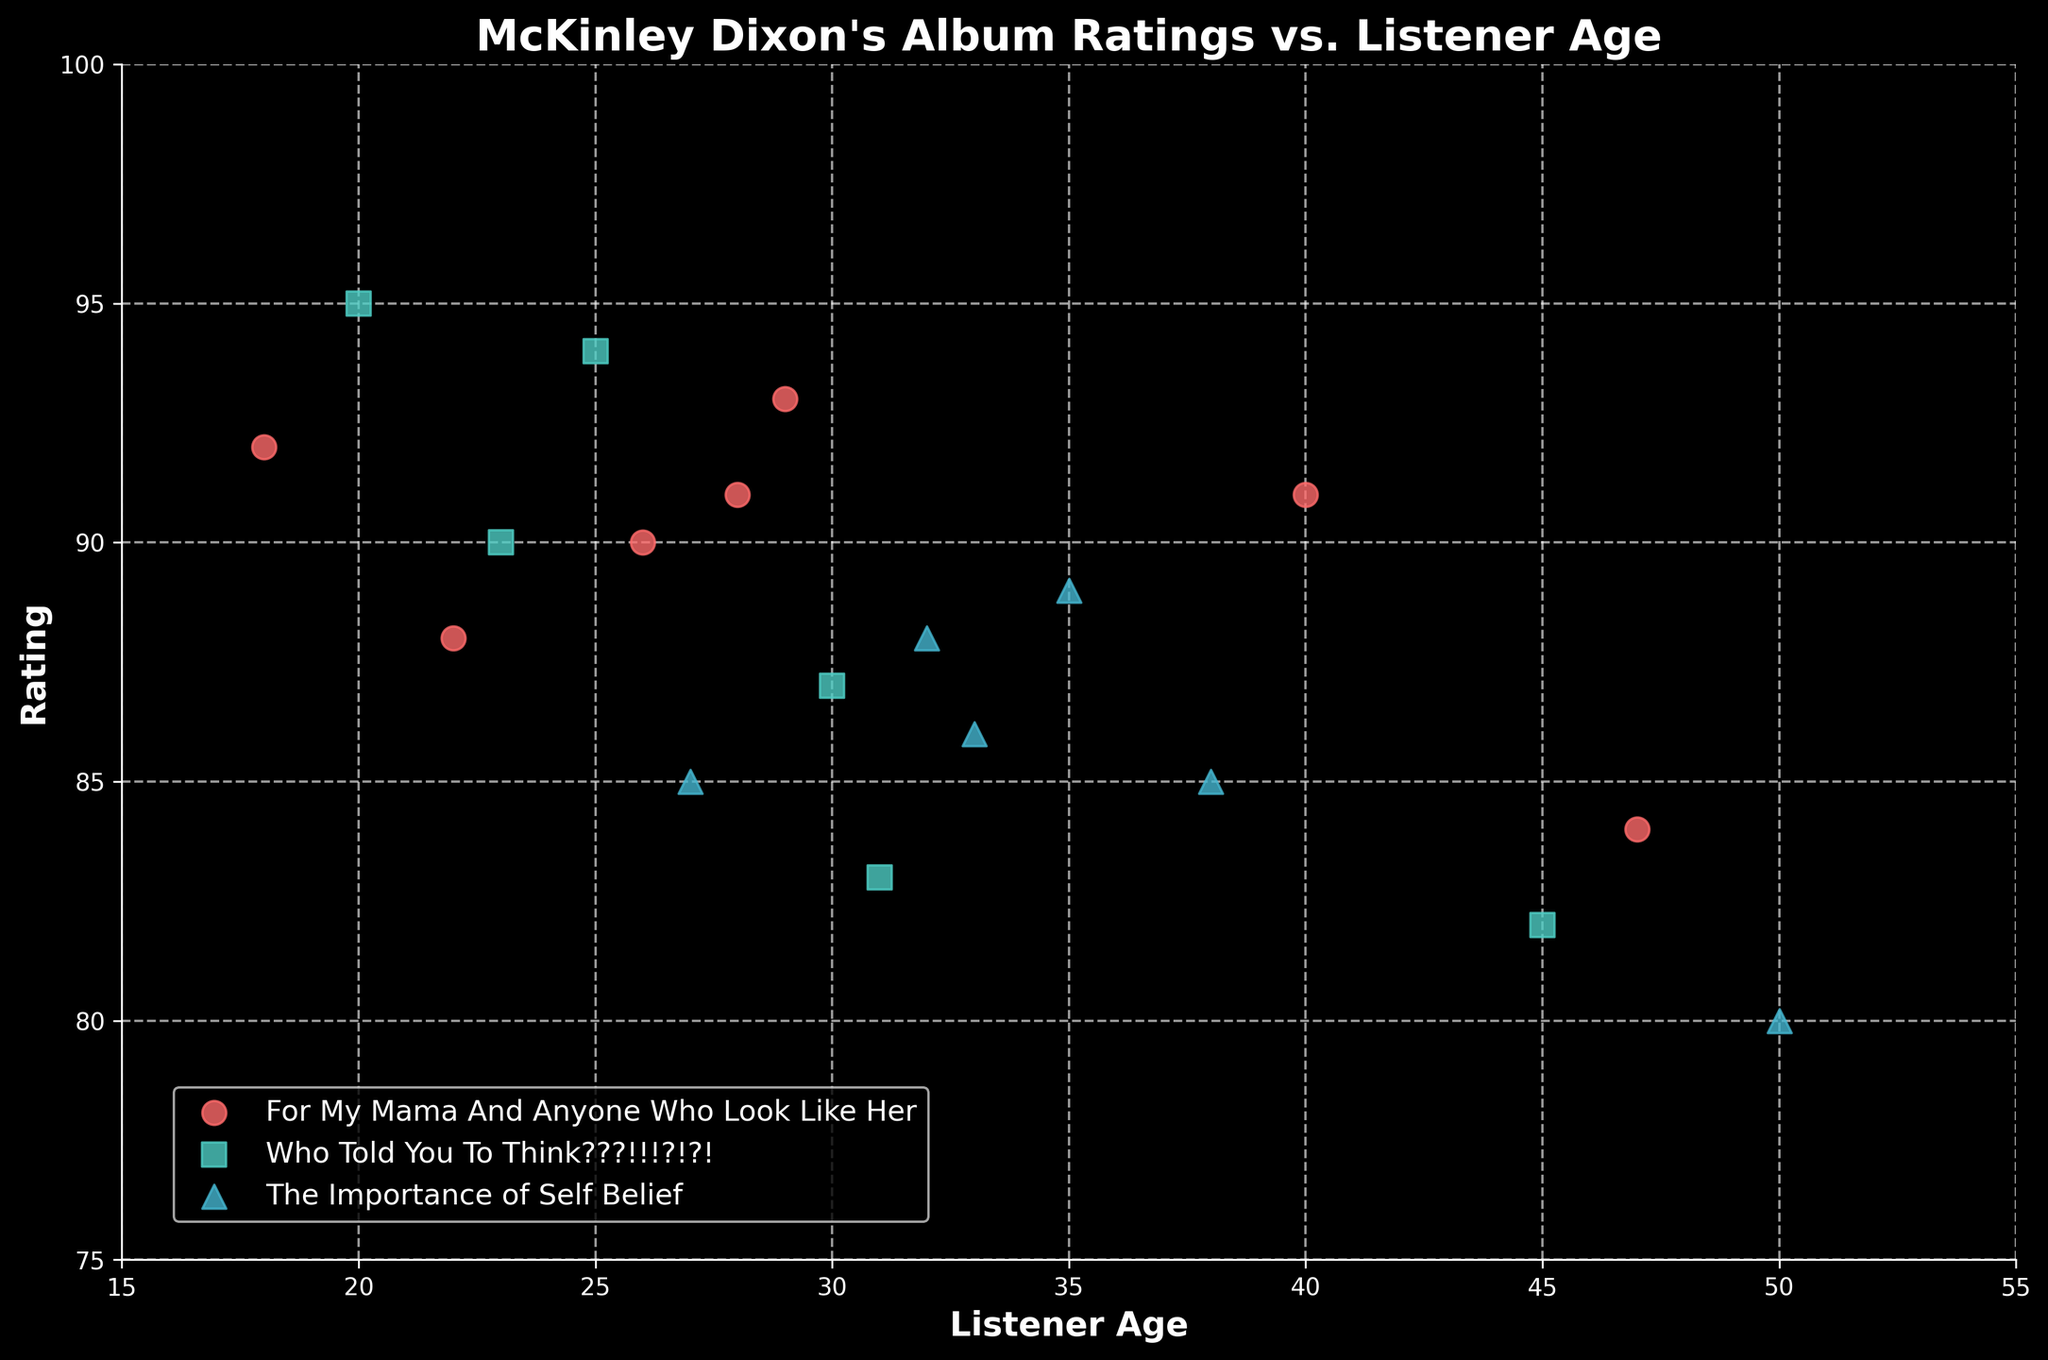what is the title of the plot? The title is usually the largest text at the top of the figure, describing the main topic of the plot. In this case, it tells us about McKinley Dixon's album ratings in relation to listener ages.
Answer: McKinley Dixon's Album Ratings vs. Listener Age What are the labels for the axes? The x-axis label is typically on the horizontal axis and the y-axis label is on the vertical axis. These labels describe what data is presented on each axis.
Answer: x-axis: Listener Age, y-axis: Rating How many unique albums are depicted in the plot? To determine the number of unique albums, count the distinct categories marked by different colors and symbols in the legend.
Answer: Three Which album has the highest rating by listeners aged 20? To find this, locate the data points on the plot corresponding to a listener age of 20, and then identify which album has the highest rating.
Answer: Who Told You To Think???!!!?!?! (95) For listeners aged 29, what is the rating for "For My Mama And Anyone Who Look Like Her"? Locate the data point where the listener age is 29 and check the corresponding rating for the specified album.
Answer: 93 What's the range of listener ages for "The Importance of Self Belief"? Identify the minimum and maximum listener ages associated with this album by looking at the spread of data points for it on the x-axis.
Answer: 27 to 50 Which age group gave "Who Told You To Think???!!!?!?!" the lowest rating? Identify the data point with the lowest rating for this album and check the corresponding listener age on the x-axis.
Answer: 45 How does the average rating of "For My Mama And Anyone Who Look Like Her" compare to "The Importance of Self Belief"? Calculate the average ratings by summing the ratings for each album and dividing by the number of data points, then compare the two averages.
Answer: "For My Mama And Anyone Who Look Like Her" has a higher average rating What is the distribution of ratings for listeners aged under 30 vs. those aged 30 and above? Separate the data points into two groups based on the listener age, calculate the ratings for each group, and describe any noticeable trends.
Answer: Listeners under 30 tend to give higher ratings Which album appears to have the most consistent ratings across different age groups? Look for the album with the least variation in rating across the different age groups, which would appear as a tight cluster of data points in the plot.
Answer: The Importance of Self Belief 